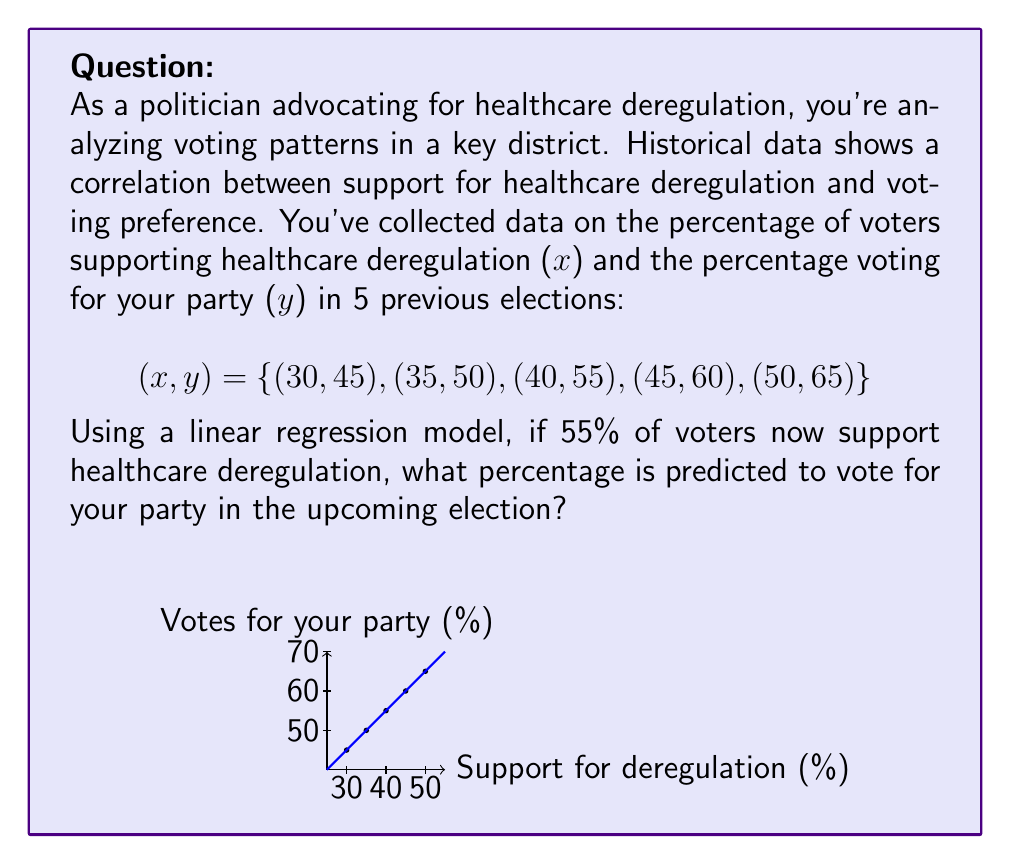Can you solve this math problem? To solve this problem, we'll use the linear regression model:

1) First, calculate the means of x and y:
   $\bar{x} = \frac{30 + 35 + 40 + 45 + 50}{5} = 40$
   $\bar{y} = \frac{45 + 50 + 55 + 60 + 65}{5} = 55$

2) Calculate the slope (m) using the formula:
   $m = \frac{\sum (x_i - \bar{x})(y_i - \bar{y})}{\sum (x_i - \bar{x})^2}$

   $\sum (x_i - \bar{x})(y_i - \bar{y}) = (-10)(-10) + (-5)(-5) + (0)(0) + (5)(5) + (10)(10) = 250$
   $\sum (x_i - \bar{x})^2 = (-10)^2 + (-5)^2 + 0^2 + 5^2 + 10^2 = 250$

   $m = \frac{250}{250} = 1$

3) Calculate the y-intercept (b) using the formula:
   $b = \bar{y} - m\bar{x} = 55 - 1(40) = 15$

4) The linear regression equation is:
   $y = mx + b = 1x + 15$

5) For x = 55 (55% support for deregulation), calculate y:
   $y = 1(55) + 15 = 70$

Therefore, the model predicts 70% of voters will vote for your party.
Answer: 70% 